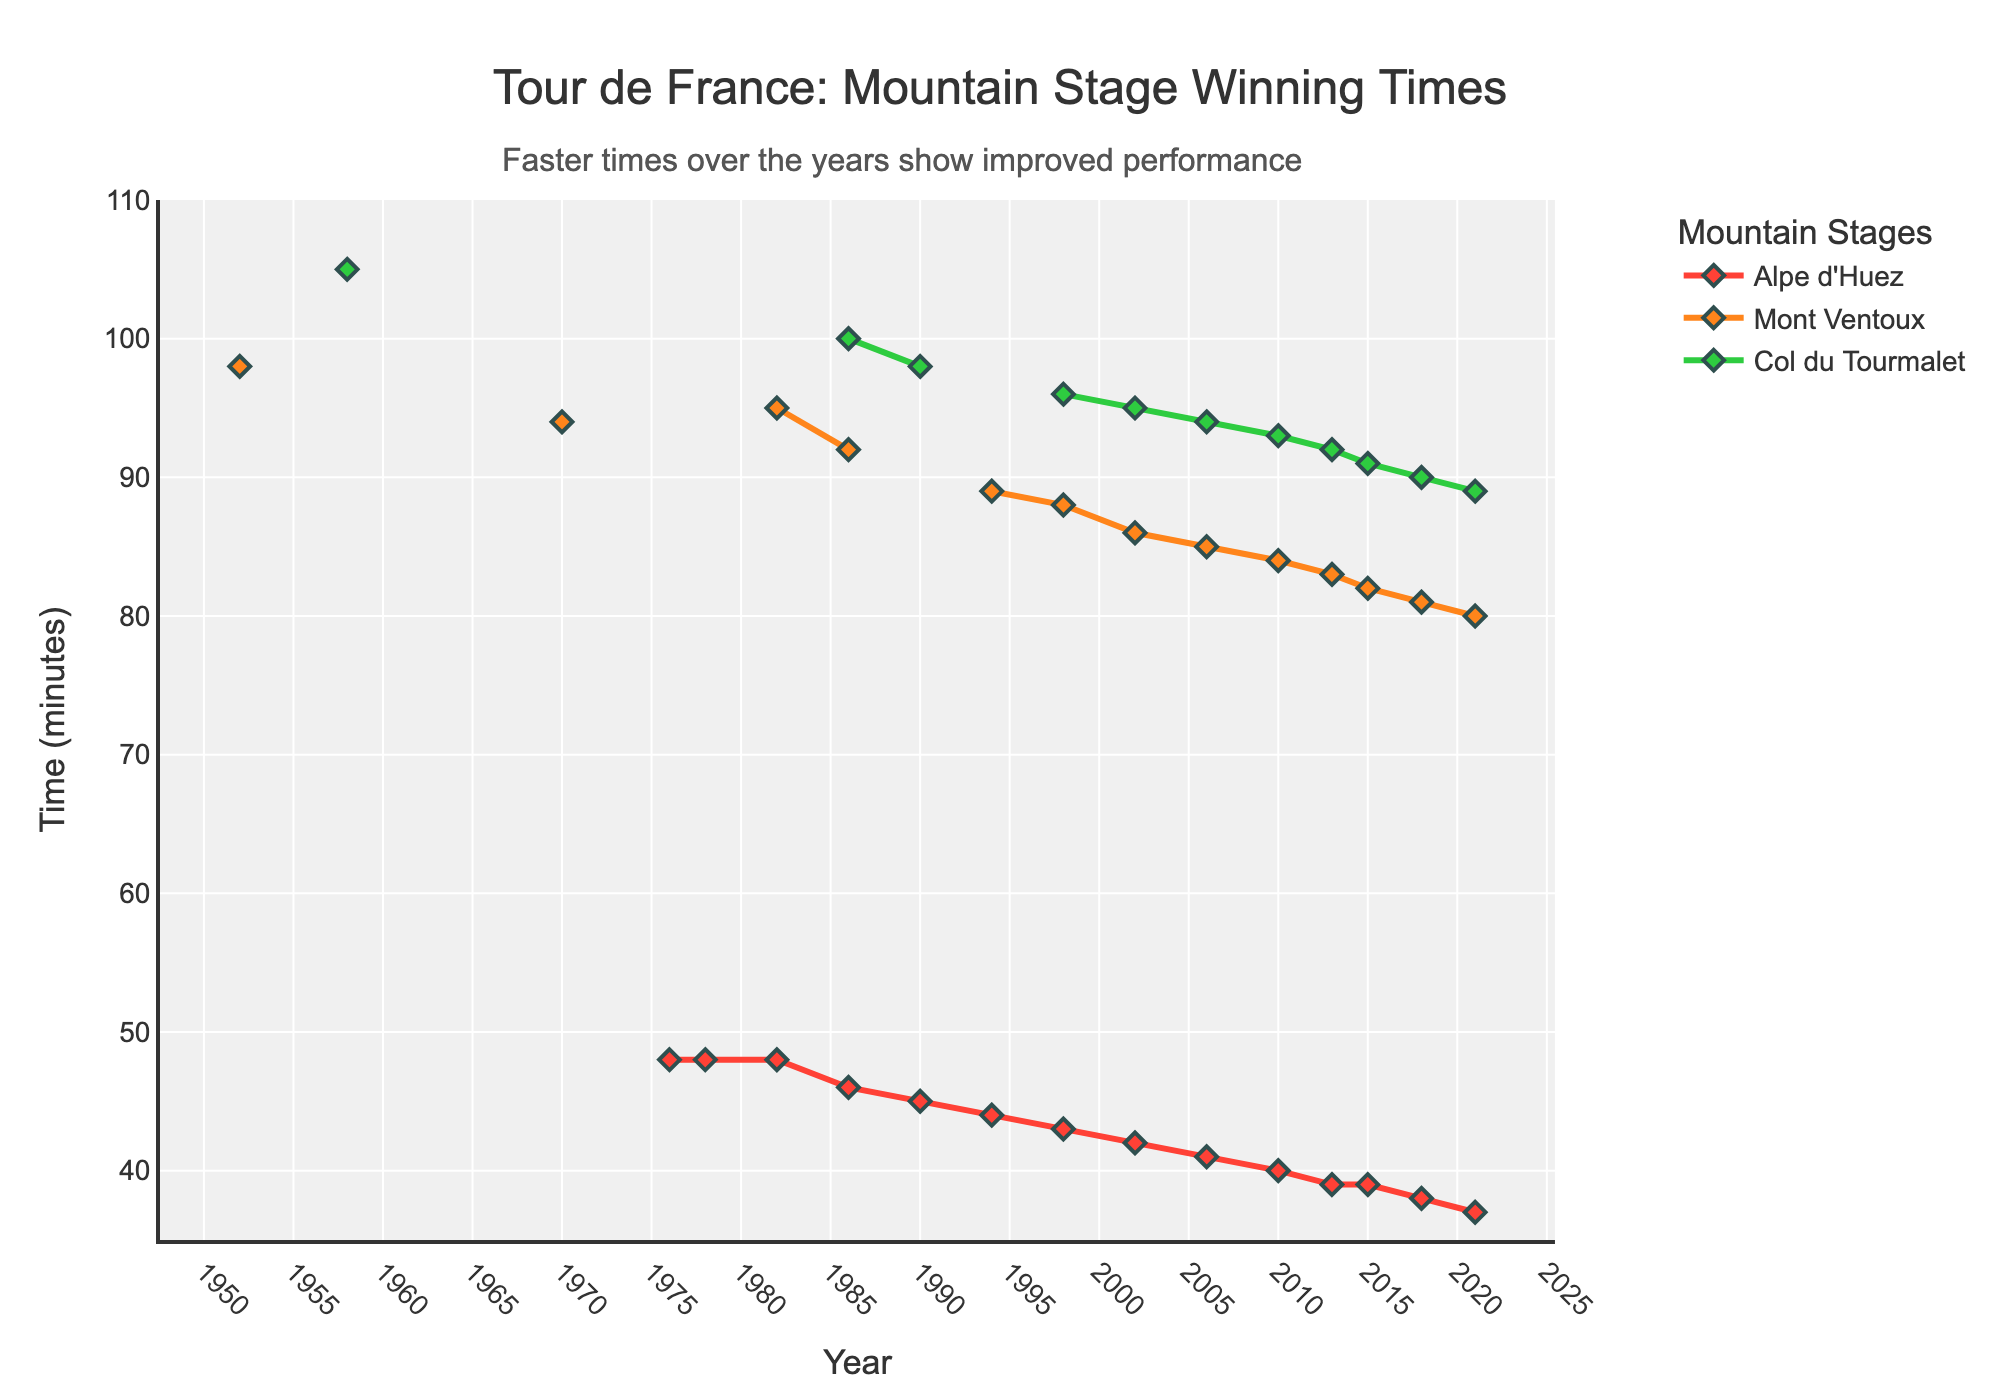What's the fastest winning time for Alpe d'Huez and in which year was it achieved? To find this, look for the minimum time in the Alpe d'Huez line. The fastest time is 37 minutes in 2021.
Answer: 37 minutes, 2021 Which stage shows the greatest reduction in winning time from the 1950s to 2020s? Compare the time differences between the 1950s and 2020s for all three stages. The Alpe d'Huez went from no record in 1950s to 37 minutes in 2021, Mont Ventoux went from 98 minutes in 1952 to 80 minutes in 2021, and Col du Tourmalet from 105 minutes in 1958 to 89 minutes in 2021. Mont Ventoux shows the greatest reduction.
Answer: Mont Ventoux How many years did it take for the winning time at Mont Ventoux to decrease from 98 minutes to 80 minutes? Look at the years and corresponding times for Mont Ventoux. The winning time decreased from 98 minutes in 1952 to 80 minutes in 2021, so it took 2021 - 1952 = 69 years.
Answer: 69 years Which mountain stage had the slowest winning time recorded in recent data (2021)? Check the values for the year 2021 for each mountain stage: Alpe d'Huez (37 minutes), Mont Ventoux (80 minutes), Col du Tourmalet (89 minutes). The slowest time is for Col du Tourmalet.
Answer: Col du Tourmalet What is the approximate average winning time for the Alpe d'Huez stage over the recorded years? To calculate the average, sum all recorded times for Alpe d'Huez and divide by the number of records. (48 + 48 + 48 + 46 + 45 + 44 + 43 + 42 + 41 + 40 + 39 + 39 + 38 + 37) / 14 ≈ 42.1 minutes.
Answer: 42.1 minutes Between which two consecutive years did the winning time for Col du Tourmalet decrease the most? Look at the times for Col du Tourmalet across the years and calculate the differences. The largest decrease is from 100 minutes in 1986 to 98 minutes in 1990, which is a decrease of 2 minutes.
Answer: 1986 and 1990 Did any stage show a consistent improvement (i.e., no increase in time) from the earliest to the latest year? Examine each stage’s trend line to see if there are any increases in their progression. Alpe d'Huez shows a consistent decrease with no increase in times.
Answer: Alpe d'Huez Do the Mont Ventoux and Col du Tourmalet times cross each other at any point? Look at the plot where both lines for Mont Ventoux and Col du Tourmalet might intersect. No intersection point is observed.
Answer: No 